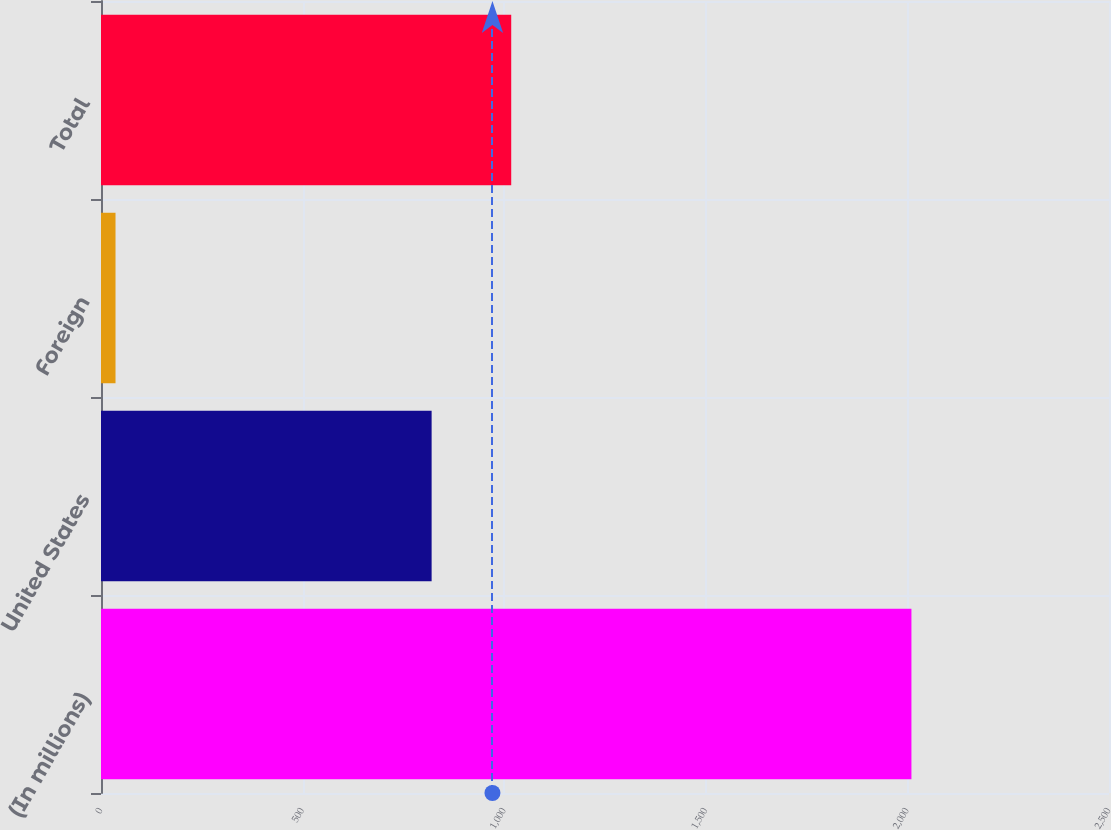Convert chart. <chart><loc_0><loc_0><loc_500><loc_500><bar_chart><fcel>(In millions)<fcel>United States<fcel>Foreign<fcel>Total<nl><fcel>2010<fcel>820<fcel>36<fcel>1017.4<nl></chart> 